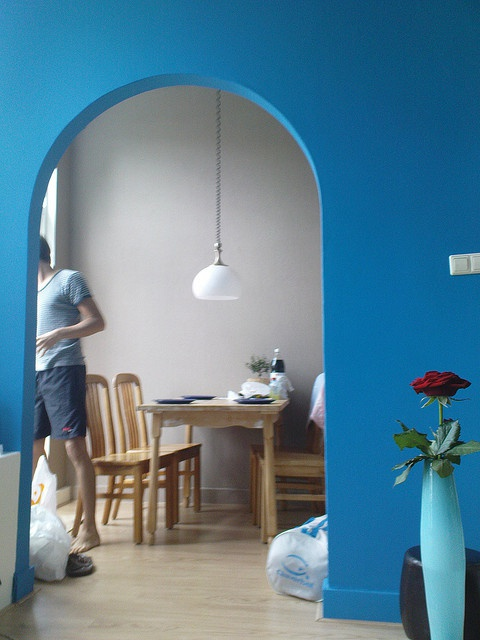Describe the objects in this image and their specific colors. I can see people in teal, gray, black, blue, and white tones, dining table in teal, gray, and lightgray tones, vase in teal and lightblue tones, chair in teal, maroon, and gray tones, and chair in teal, gray, black, and maroon tones in this image. 